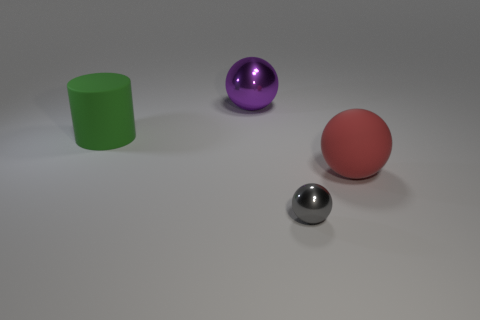What is the big red thing made of?
Keep it short and to the point. Rubber. What is the shape of the matte thing that is to the left of the big purple shiny ball?
Provide a succinct answer. Cylinder. Is there a brown metal object of the same size as the green rubber object?
Keep it short and to the point. No. Is the material of the large sphere that is right of the small gray metal object the same as the gray thing?
Your response must be concise. No. Are there the same number of big purple metal things on the right side of the tiny shiny object and large matte spheres behind the big cylinder?
Your answer should be very brief. Yes. What shape is the thing that is both right of the purple metallic object and behind the gray sphere?
Make the answer very short. Sphere. How many big spheres are in front of the large matte cylinder?
Give a very brief answer. 1. How many other objects are the same shape as the big purple thing?
Offer a terse response. 2. Are there fewer green objects than large blue balls?
Provide a short and direct response. No. There is a sphere that is both behind the tiny metallic object and to the right of the large metal thing; what size is it?
Ensure brevity in your answer.  Large. 